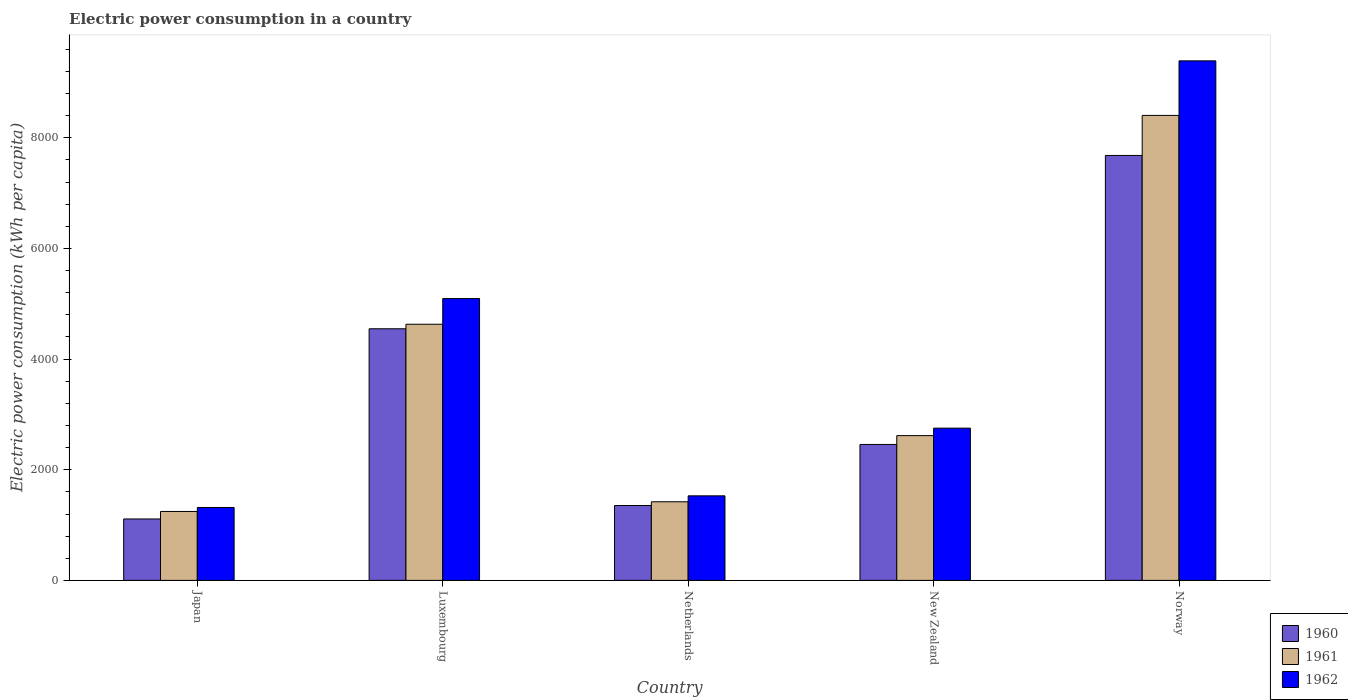Are the number of bars per tick equal to the number of legend labels?
Make the answer very short. Yes. Are the number of bars on each tick of the X-axis equal?
Make the answer very short. Yes. How many bars are there on the 5th tick from the left?
Make the answer very short. 3. How many bars are there on the 3rd tick from the right?
Offer a terse response. 3. What is the electric power consumption in in 1961 in Netherlands?
Give a very brief answer. 1421.03. Across all countries, what is the maximum electric power consumption in in 1961?
Your answer should be compact. 8404.62. Across all countries, what is the minimum electric power consumption in in 1962?
Provide a succinct answer. 1317.93. In which country was the electric power consumption in in 1960 maximum?
Your answer should be very brief. Norway. What is the total electric power consumption in in 1961 in the graph?
Provide a short and direct response. 1.83e+04. What is the difference between the electric power consumption in in 1962 in Netherlands and that in New Zealand?
Provide a short and direct response. -1223.31. What is the difference between the electric power consumption in in 1960 in Netherlands and the electric power consumption in in 1962 in Norway?
Keep it short and to the point. -8037.58. What is the average electric power consumption in in 1961 per country?
Offer a terse response. 3663.71. What is the difference between the electric power consumption in of/in 1960 and electric power consumption in of/in 1961 in Norway?
Keep it short and to the point. -723.48. In how many countries, is the electric power consumption in in 1961 greater than 2000 kWh per capita?
Your answer should be very brief. 3. What is the ratio of the electric power consumption in in 1961 in New Zealand to that in Norway?
Ensure brevity in your answer.  0.31. What is the difference between the highest and the second highest electric power consumption in in 1962?
Offer a very short reply. -4296.67. What is the difference between the highest and the lowest electric power consumption in in 1960?
Offer a very short reply. 6570.88. In how many countries, is the electric power consumption in in 1962 greater than the average electric power consumption in in 1962 taken over all countries?
Offer a very short reply. 2. Is the sum of the electric power consumption in in 1960 in Luxembourg and New Zealand greater than the maximum electric power consumption in in 1961 across all countries?
Provide a short and direct response. No. What does the 3rd bar from the left in Japan represents?
Keep it short and to the point. 1962. What does the 2nd bar from the right in Norway represents?
Your answer should be very brief. 1961. Is it the case that in every country, the sum of the electric power consumption in in 1961 and electric power consumption in in 1962 is greater than the electric power consumption in in 1960?
Your answer should be very brief. Yes. How many bars are there?
Provide a short and direct response. 15. What is the difference between two consecutive major ticks on the Y-axis?
Offer a very short reply. 2000. Are the values on the major ticks of Y-axis written in scientific E-notation?
Provide a succinct answer. No. Does the graph contain grids?
Your answer should be very brief. No. What is the title of the graph?
Make the answer very short. Electric power consumption in a country. Does "1989" appear as one of the legend labels in the graph?
Ensure brevity in your answer.  No. What is the label or title of the X-axis?
Your answer should be compact. Country. What is the label or title of the Y-axis?
Your response must be concise. Electric power consumption (kWh per capita). What is the Electric power consumption (kWh per capita) in 1960 in Japan?
Provide a succinct answer. 1110.26. What is the Electric power consumption (kWh per capita) in 1961 in Japan?
Ensure brevity in your answer.  1246.01. What is the Electric power consumption (kWh per capita) in 1962 in Japan?
Offer a terse response. 1317.93. What is the Electric power consumption (kWh per capita) in 1960 in Luxembourg?
Offer a very short reply. 4548.21. What is the Electric power consumption (kWh per capita) of 1961 in Luxembourg?
Give a very brief answer. 4630.02. What is the Electric power consumption (kWh per capita) in 1962 in Luxembourg?
Keep it short and to the point. 5094.31. What is the Electric power consumption (kWh per capita) in 1960 in Netherlands?
Offer a very short reply. 1353.4. What is the Electric power consumption (kWh per capita) of 1961 in Netherlands?
Keep it short and to the point. 1421.03. What is the Electric power consumption (kWh per capita) in 1962 in Netherlands?
Keep it short and to the point. 1528.5. What is the Electric power consumption (kWh per capita) of 1960 in New Zealand?
Your answer should be compact. 2457.21. What is the Electric power consumption (kWh per capita) in 1961 in New Zealand?
Make the answer very short. 2616.85. What is the Electric power consumption (kWh per capita) of 1962 in New Zealand?
Keep it short and to the point. 2751.81. What is the Electric power consumption (kWh per capita) of 1960 in Norway?
Offer a very short reply. 7681.14. What is the Electric power consumption (kWh per capita) in 1961 in Norway?
Make the answer very short. 8404.62. What is the Electric power consumption (kWh per capita) in 1962 in Norway?
Ensure brevity in your answer.  9390.98. Across all countries, what is the maximum Electric power consumption (kWh per capita) of 1960?
Give a very brief answer. 7681.14. Across all countries, what is the maximum Electric power consumption (kWh per capita) in 1961?
Provide a short and direct response. 8404.62. Across all countries, what is the maximum Electric power consumption (kWh per capita) in 1962?
Your response must be concise. 9390.98. Across all countries, what is the minimum Electric power consumption (kWh per capita) in 1960?
Make the answer very short. 1110.26. Across all countries, what is the minimum Electric power consumption (kWh per capita) in 1961?
Your answer should be very brief. 1246.01. Across all countries, what is the minimum Electric power consumption (kWh per capita) of 1962?
Ensure brevity in your answer.  1317.93. What is the total Electric power consumption (kWh per capita) of 1960 in the graph?
Offer a very short reply. 1.72e+04. What is the total Electric power consumption (kWh per capita) of 1961 in the graph?
Your answer should be very brief. 1.83e+04. What is the total Electric power consumption (kWh per capita) of 1962 in the graph?
Give a very brief answer. 2.01e+04. What is the difference between the Electric power consumption (kWh per capita) of 1960 in Japan and that in Luxembourg?
Your answer should be compact. -3437.94. What is the difference between the Electric power consumption (kWh per capita) of 1961 in Japan and that in Luxembourg?
Your answer should be compact. -3384.01. What is the difference between the Electric power consumption (kWh per capita) in 1962 in Japan and that in Luxembourg?
Provide a succinct answer. -3776.38. What is the difference between the Electric power consumption (kWh per capita) in 1960 in Japan and that in Netherlands?
Keep it short and to the point. -243.14. What is the difference between the Electric power consumption (kWh per capita) in 1961 in Japan and that in Netherlands?
Provide a succinct answer. -175.02. What is the difference between the Electric power consumption (kWh per capita) in 1962 in Japan and that in Netherlands?
Make the answer very short. -210.57. What is the difference between the Electric power consumption (kWh per capita) in 1960 in Japan and that in New Zealand?
Provide a short and direct response. -1346.94. What is the difference between the Electric power consumption (kWh per capita) of 1961 in Japan and that in New Zealand?
Keep it short and to the point. -1370.84. What is the difference between the Electric power consumption (kWh per capita) of 1962 in Japan and that in New Zealand?
Your answer should be compact. -1433.88. What is the difference between the Electric power consumption (kWh per capita) of 1960 in Japan and that in Norway?
Provide a short and direct response. -6570.88. What is the difference between the Electric power consumption (kWh per capita) of 1961 in Japan and that in Norway?
Offer a very short reply. -7158.61. What is the difference between the Electric power consumption (kWh per capita) of 1962 in Japan and that in Norway?
Provide a succinct answer. -8073.05. What is the difference between the Electric power consumption (kWh per capita) in 1960 in Luxembourg and that in Netherlands?
Give a very brief answer. 3194.81. What is the difference between the Electric power consumption (kWh per capita) of 1961 in Luxembourg and that in Netherlands?
Your answer should be very brief. 3208.99. What is the difference between the Electric power consumption (kWh per capita) of 1962 in Luxembourg and that in Netherlands?
Ensure brevity in your answer.  3565.81. What is the difference between the Electric power consumption (kWh per capita) of 1960 in Luxembourg and that in New Zealand?
Your answer should be very brief. 2091. What is the difference between the Electric power consumption (kWh per capita) of 1961 in Luxembourg and that in New Zealand?
Provide a succinct answer. 2013.17. What is the difference between the Electric power consumption (kWh per capita) in 1962 in Luxembourg and that in New Zealand?
Offer a terse response. 2342.5. What is the difference between the Electric power consumption (kWh per capita) in 1960 in Luxembourg and that in Norway?
Make the answer very short. -3132.94. What is the difference between the Electric power consumption (kWh per capita) of 1961 in Luxembourg and that in Norway?
Your answer should be very brief. -3774.6. What is the difference between the Electric power consumption (kWh per capita) in 1962 in Luxembourg and that in Norway?
Your response must be concise. -4296.67. What is the difference between the Electric power consumption (kWh per capita) of 1960 in Netherlands and that in New Zealand?
Keep it short and to the point. -1103.81. What is the difference between the Electric power consumption (kWh per capita) of 1961 in Netherlands and that in New Zealand?
Make the answer very short. -1195.82. What is the difference between the Electric power consumption (kWh per capita) of 1962 in Netherlands and that in New Zealand?
Ensure brevity in your answer.  -1223.31. What is the difference between the Electric power consumption (kWh per capita) in 1960 in Netherlands and that in Norway?
Provide a succinct answer. -6327.74. What is the difference between the Electric power consumption (kWh per capita) in 1961 in Netherlands and that in Norway?
Offer a terse response. -6983.59. What is the difference between the Electric power consumption (kWh per capita) of 1962 in Netherlands and that in Norway?
Provide a short and direct response. -7862.48. What is the difference between the Electric power consumption (kWh per capita) of 1960 in New Zealand and that in Norway?
Offer a very short reply. -5223.94. What is the difference between the Electric power consumption (kWh per capita) in 1961 in New Zealand and that in Norway?
Your answer should be compact. -5787.77. What is the difference between the Electric power consumption (kWh per capita) in 1962 in New Zealand and that in Norway?
Your answer should be very brief. -6639.17. What is the difference between the Electric power consumption (kWh per capita) in 1960 in Japan and the Electric power consumption (kWh per capita) in 1961 in Luxembourg?
Your response must be concise. -3519.76. What is the difference between the Electric power consumption (kWh per capita) in 1960 in Japan and the Electric power consumption (kWh per capita) in 1962 in Luxembourg?
Make the answer very short. -3984.05. What is the difference between the Electric power consumption (kWh per capita) of 1961 in Japan and the Electric power consumption (kWh per capita) of 1962 in Luxembourg?
Offer a terse response. -3848.3. What is the difference between the Electric power consumption (kWh per capita) of 1960 in Japan and the Electric power consumption (kWh per capita) of 1961 in Netherlands?
Offer a terse response. -310.77. What is the difference between the Electric power consumption (kWh per capita) in 1960 in Japan and the Electric power consumption (kWh per capita) in 1962 in Netherlands?
Make the answer very short. -418.24. What is the difference between the Electric power consumption (kWh per capita) of 1961 in Japan and the Electric power consumption (kWh per capita) of 1962 in Netherlands?
Your response must be concise. -282.49. What is the difference between the Electric power consumption (kWh per capita) of 1960 in Japan and the Electric power consumption (kWh per capita) of 1961 in New Zealand?
Give a very brief answer. -1506.59. What is the difference between the Electric power consumption (kWh per capita) in 1960 in Japan and the Electric power consumption (kWh per capita) in 1962 in New Zealand?
Your response must be concise. -1641.55. What is the difference between the Electric power consumption (kWh per capita) in 1961 in Japan and the Electric power consumption (kWh per capita) in 1962 in New Zealand?
Your answer should be very brief. -1505.8. What is the difference between the Electric power consumption (kWh per capita) in 1960 in Japan and the Electric power consumption (kWh per capita) in 1961 in Norway?
Keep it short and to the point. -7294.36. What is the difference between the Electric power consumption (kWh per capita) in 1960 in Japan and the Electric power consumption (kWh per capita) in 1962 in Norway?
Ensure brevity in your answer.  -8280.71. What is the difference between the Electric power consumption (kWh per capita) of 1961 in Japan and the Electric power consumption (kWh per capita) of 1962 in Norway?
Provide a succinct answer. -8144.97. What is the difference between the Electric power consumption (kWh per capita) in 1960 in Luxembourg and the Electric power consumption (kWh per capita) in 1961 in Netherlands?
Your response must be concise. 3127.17. What is the difference between the Electric power consumption (kWh per capita) in 1960 in Luxembourg and the Electric power consumption (kWh per capita) in 1962 in Netherlands?
Your answer should be compact. 3019.7. What is the difference between the Electric power consumption (kWh per capita) in 1961 in Luxembourg and the Electric power consumption (kWh per capita) in 1962 in Netherlands?
Provide a short and direct response. 3101.52. What is the difference between the Electric power consumption (kWh per capita) in 1960 in Luxembourg and the Electric power consumption (kWh per capita) in 1961 in New Zealand?
Offer a very short reply. 1931.35. What is the difference between the Electric power consumption (kWh per capita) in 1960 in Luxembourg and the Electric power consumption (kWh per capita) in 1962 in New Zealand?
Provide a succinct answer. 1796.39. What is the difference between the Electric power consumption (kWh per capita) in 1961 in Luxembourg and the Electric power consumption (kWh per capita) in 1962 in New Zealand?
Provide a succinct answer. 1878.21. What is the difference between the Electric power consumption (kWh per capita) in 1960 in Luxembourg and the Electric power consumption (kWh per capita) in 1961 in Norway?
Offer a very short reply. -3856.42. What is the difference between the Electric power consumption (kWh per capita) of 1960 in Luxembourg and the Electric power consumption (kWh per capita) of 1962 in Norway?
Your answer should be compact. -4842.77. What is the difference between the Electric power consumption (kWh per capita) in 1961 in Luxembourg and the Electric power consumption (kWh per capita) in 1962 in Norway?
Offer a terse response. -4760.95. What is the difference between the Electric power consumption (kWh per capita) of 1960 in Netherlands and the Electric power consumption (kWh per capita) of 1961 in New Zealand?
Your answer should be compact. -1263.45. What is the difference between the Electric power consumption (kWh per capita) of 1960 in Netherlands and the Electric power consumption (kWh per capita) of 1962 in New Zealand?
Offer a very short reply. -1398.41. What is the difference between the Electric power consumption (kWh per capita) of 1961 in Netherlands and the Electric power consumption (kWh per capita) of 1962 in New Zealand?
Your answer should be compact. -1330.78. What is the difference between the Electric power consumption (kWh per capita) of 1960 in Netherlands and the Electric power consumption (kWh per capita) of 1961 in Norway?
Your answer should be compact. -7051.22. What is the difference between the Electric power consumption (kWh per capita) in 1960 in Netherlands and the Electric power consumption (kWh per capita) in 1962 in Norway?
Provide a short and direct response. -8037.58. What is the difference between the Electric power consumption (kWh per capita) of 1961 in Netherlands and the Electric power consumption (kWh per capita) of 1962 in Norway?
Your response must be concise. -7969.94. What is the difference between the Electric power consumption (kWh per capita) in 1960 in New Zealand and the Electric power consumption (kWh per capita) in 1961 in Norway?
Ensure brevity in your answer.  -5947.42. What is the difference between the Electric power consumption (kWh per capita) of 1960 in New Zealand and the Electric power consumption (kWh per capita) of 1962 in Norway?
Give a very brief answer. -6933.77. What is the difference between the Electric power consumption (kWh per capita) in 1961 in New Zealand and the Electric power consumption (kWh per capita) in 1962 in Norway?
Your answer should be very brief. -6774.12. What is the average Electric power consumption (kWh per capita) of 1960 per country?
Make the answer very short. 3430.04. What is the average Electric power consumption (kWh per capita) in 1961 per country?
Offer a very short reply. 3663.71. What is the average Electric power consumption (kWh per capita) of 1962 per country?
Offer a very short reply. 4016.71. What is the difference between the Electric power consumption (kWh per capita) in 1960 and Electric power consumption (kWh per capita) in 1961 in Japan?
Offer a very short reply. -135.75. What is the difference between the Electric power consumption (kWh per capita) in 1960 and Electric power consumption (kWh per capita) in 1962 in Japan?
Your answer should be compact. -207.67. What is the difference between the Electric power consumption (kWh per capita) in 1961 and Electric power consumption (kWh per capita) in 1962 in Japan?
Make the answer very short. -71.92. What is the difference between the Electric power consumption (kWh per capita) in 1960 and Electric power consumption (kWh per capita) in 1961 in Luxembourg?
Offer a very short reply. -81.82. What is the difference between the Electric power consumption (kWh per capita) of 1960 and Electric power consumption (kWh per capita) of 1962 in Luxembourg?
Provide a short and direct response. -546.11. What is the difference between the Electric power consumption (kWh per capita) in 1961 and Electric power consumption (kWh per capita) in 1962 in Luxembourg?
Offer a very short reply. -464.29. What is the difference between the Electric power consumption (kWh per capita) in 1960 and Electric power consumption (kWh per capita) in 1961 in Netherlands?
Ensure brevity in your answer.  -67.63. What is the difference between the Electric power consumption (kWh per capita) in 1960 and Electric power consumption (kWh per capita) in 1962 in Netherlands?
Your answer should be compact. -175.1. What is the difference between the Electric power consumption (kWh per capita) of 1961 and Electric power consumption (kWh per capita) of 1962 in Netherlands?
Your answer should be very brief. -107.47. What is the difference between the Electric power consumption (kWh per capita) of 1960 and Electric power consumption (kWh per capita) of 1961 in New Zealand?
Give a very brief answer. -159.65. What is the difference between the Electric power consumption (kWh per capita) of 1960 and Electric power consumption (kWh per capita) of 1962 in New Zealand?
Your answer should be compact. -294.61. What is the difference between the Electric power consumption (kWh per capita) of 1961 and Electric power consumption (kWh per capita) of 1962 in New Zealand?
Your answer should be compact. -134.96. What is the difference between the Electric power consumption (kWh per capita) of 1960 and Electric power consumption (kWh per capita) of 1961 in Norway?
Offer a terse response. -723.48. What is the difference between the Electric power consumption (kWh per capita) in 1960 and Electric power consumption (kWh per capita) in 1962 in Norway?
Keep it short and to the point. -1709.84. What is the difference between the Electric power consumption (kWh per capita) of 1961 and Electric power consumption (kWh per capita) of 1962 in Norway?
Your answer should be very brief. -986.36. What is the ratio of the Electric power consumption (kWh per capita) in 1960 in Japan to that in Luxembourg?
Ensure brevity in your answer.  0.24. What is the ratio of the Electric power consumption (kWh per capita) of 1961 in Japan to that in Luxembourg?
Provide a succinct answer. 0.27. What is the ratio of the Electric power consumption (kWh per capita) in 1962 in Japan to that in Luxembourg?
Provide a succinct answer. 0.26. What is the ratio of the Electric power consumption (kWh per capita) in 1960 in Japan to that in Netherlands?
Offer a terse response. 0.82. What is the ratio of the Electric power consumption (kWh per capita) in 1961 in Japan to that in Netherlands?
Give a very brief answer. 0.88. What is the ratio of the Electric power consumption (kWh per capita) of 1962 in Japan to that in Netherlands?
Provide a succinct answer. 0.86. What is the ratio of the Electric power consumption (kWh per capita) of 1960 in Japan to that in New Zealand?
Your response must be concise. 0.45. What is the ratio of the Electric power consumption (kWh per capita) of 1961 in Japan to that in New Zealand?
Keep it short and to the point. 0.48. What is the ratio of the Electric power consumption (kWh per capita) of 1962 in Japan to that in New Zealand?
Your response must be concise. 0.48. What is the ratio of the Electric power consumption (kWh per capita) of 1960 in Japan to that in Norway?
Your answer should be very brief. 0.14. What is the ratio of the Electric power consumption (kWh per capita) of 1961 in Japan to that in Norway?
Make the answer very short. 0.15. What is the ratio of the Electric power consumption (kWh per capita) in 1962 in Japan to that in Norway?
Make the answer very short. 0.14. What is the ratio of the Electric power consumption (kWh per capita) of 1960 in Luxembourg to that in Netherlands?
Ensure brevity in your answer.  3.36. What is the ratio of the Electric power consumption (kWh per capita) of 1961 in Luxembourg to that in Netherlands?
Your response must be concise. 3.26. What is the ratio of the Electric power consumption (kWh per capita) of 1962 in Luxembourg to that in Netherlands?
Provide a succinct answer. 3.33. What is the ratio of the Electric power consumption (kWh per capita) of 1960 in Luxembourg to that in New Zealand?
Your response must be concise. 1.85. What is the ratio of the Electric power consumption (kWh per capita) of 1961 in Luxembourg to that in New Zealand?
Offer a very short reply. 1.77. What is the ratio of the Electric power consumption (kWh per capita) of 1962 in Luxembourg to that in New Zealand?
Your response must be concise. 1.85. What is the ratio of the Electric power consumption (kWh per capita) in 1960 in Luxembourg to that in Norway?
Make the answer very short. 0.59. What is the ratio of the Electric power consumption (kWh per capita) of 1961 in Luxembourg to that in Norway?
Offer a terse response. 0.55. What is the ratio of the Electric power consumption (kWh per capita) of 1962 in Luxembourg to that in Norway?
Provide a short and direct response. 0.54. What is the ratio of the Electric power consumption (kWh per capita) of 1960 in Netherlands to that in New Zealand?
Your response must be concise. 0.55. What is the ratio of the Electric power consumption (kWh per capita) of 1961 in Netherlands to that in New Zealand?
Offer a very short reply. 0.54. What is the ratio of the Electric power consumption (kWh per capita) in 1962 in Netherlands to that in New Zealand?
Make the answer very short. 0.56. What is the ratio of the Electric power consumption (kWh per capita) in 1960 in Netherlands to that in Norway?
Give a very brief answer. 0.18. What is the ratio of the Electric power consumption (kWh per capita) in 1961 in Netherlands to that in Norway?
Offer a terse response. 0.17. What is the ratio of the Electric power consumption (kWh per capita) of 1962 in Netherlands to that in Norway?
Offer a terse response. 0.16. What is the ratio of the Electric power consumption (kWh per capita) of 1960 in New Zealand to that in Norway?
Your response must be concise. 0.32. What is the ratio of the Electric power consumption (kWh per capita) of 1961 in New Zealand to that in Norway?
Ensure brevity in your answer.  0.31. What is the ratio of the Electric power consumption (kWh per capita) of 1962 in New Zealand to that in Norway?
Give a very brief answer. 0.29. What is the difference between the highest and the second highest Electric power consumption (kWh per capita) of 1960?
Make the answer very short. 3132.94. What is the difference between the highest and the second highest Electric power consumption (kWh per capita) in 1961?
Your response must be concise. 3774.6. What is the difference between the highest and the second highest Electric power consumption (kWh per capita) in 1962?
Provide a succinct answer. 4296.67. What is the difference between the highest and the lowest Electric power consumption (kWh per capita) of 1960?
Your response must be concise. 6570.88. What is the difference between the highest and the lowest Electric power consumption (kWh per capita) of 1961?
Provide a succinct answer. 7158.61. What is the difference between the highest and the lowest Electric power consumption (kWh per capita) of 1962?
Offer a terse response. 8073.05. 